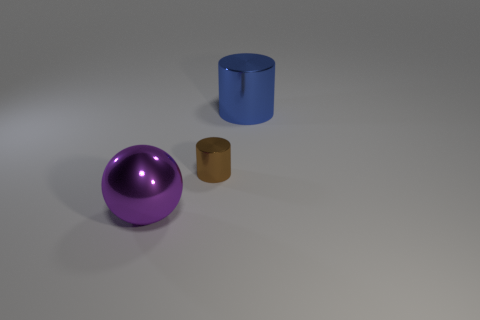Are there any large blue shiny objects that are behind the big metal object to the left of the big object that is behind the big purple metallic thing?
Provide a succinct answer. Yes. How many other things are the same shape as the purple metal object?
Your answer should be compact. 0. There is a shiny cylinder in front of the large thing that is behind the big metal thing that is to the left of the big cylinder; what color is it?
Provide a short and direct response. Brown. What number of large gray balls are there?
Make the answer very short. 0. How many big things are either cyan cylinders or blue objects?
Offer a very short reply. 1. What is the shape of the object that is the same size as the blue metallic cylinder?
Your answer should be compact. Sphere. Is there any other thing that is the same size as the brown metal cylinder?
Your answer should be compact. No. Does the blue metallic cylinder have the same size as the brown object?
Offer a very short reply. No. How many objects are big objects that are in front of the blue metallic cylinder or purple balls?
Your response must be concise. 1. There is a large shiny thing that is on the left side of the metallic object that is behind the tiny brown metal object; what is its shape?
Provide a succinct answer. Sphere. 